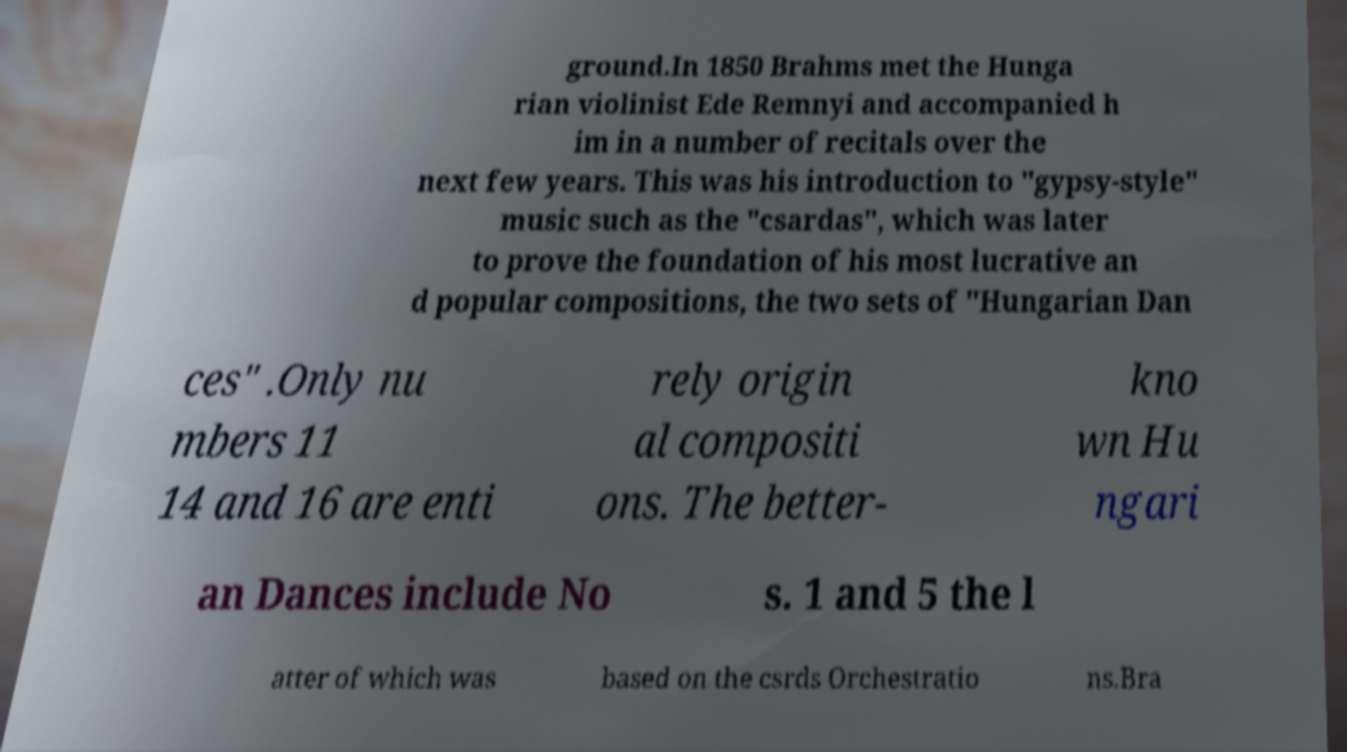I need the written content from this picture converted into text. Can you do that? ground.In 1850 Brahms met the Hunga rian violinist Ede Remnyi and accompanied h im in a number of recitals over the next few years. This was his introduction to "gypsy-style" music such as the "csardas", which was later to prove the foundation of his most lucrative an d popular compositions, the two sets of "Hungarian Dan ces" .Only nu mbers 11 14 and 16 are enti rely origin al compositi ons. The better- kno wn Hu ngari an Dances include No s. 1 and 5 the l atter of which was based on the csrds Orchestratio ns.Bra 